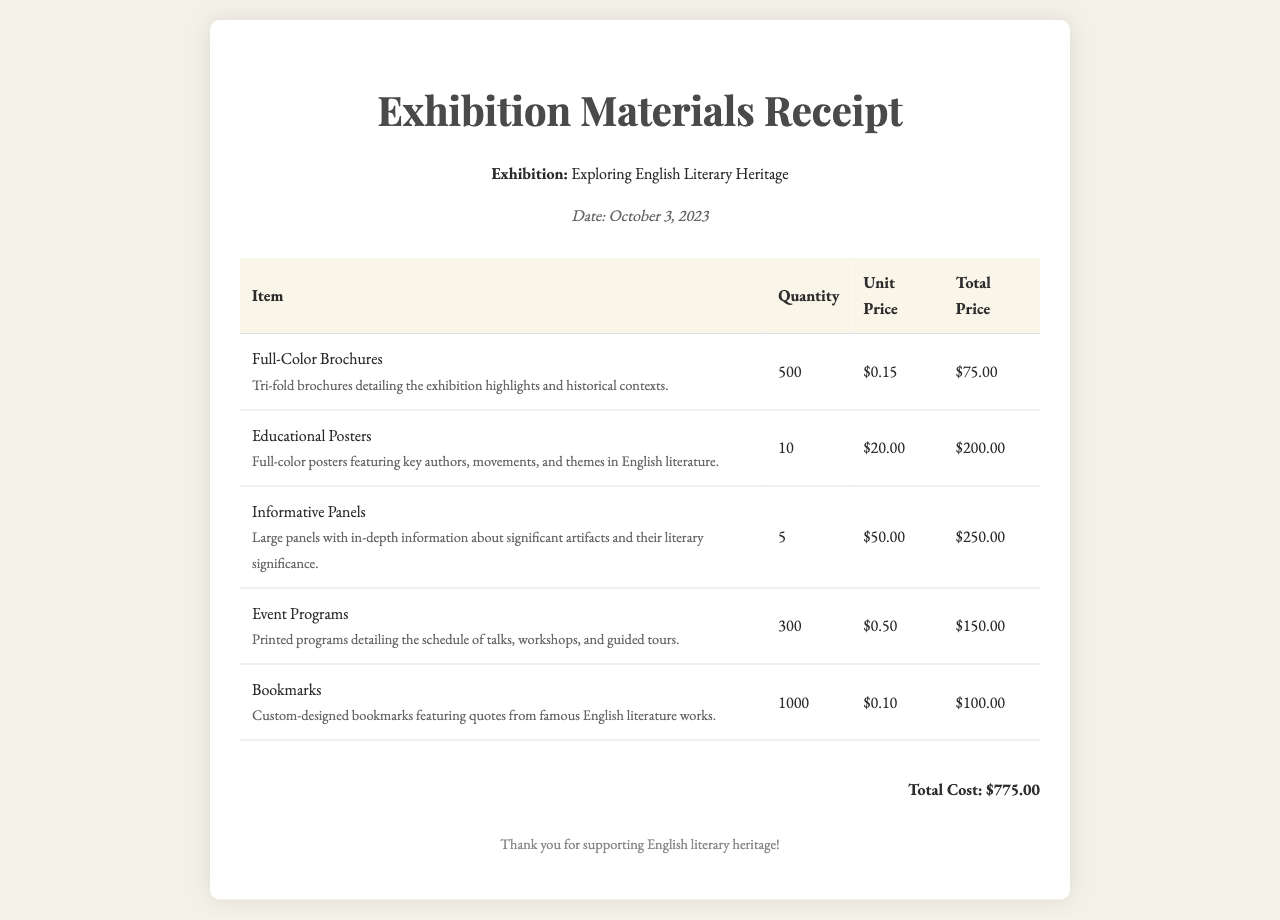What is the date of the receipt? The date is mentioned in the header of the document as October 3, 2023.
Answer: October 3, 2023 How many full-color brochures were printed? The quantity of full-color brochures is listed in the table under "Quantity" for that item, which states 500.
Answer: 500 What is the unit price of educational posters? The unit price for educational posters can be found in the table under "Unit Price," which shows $20.00.
Answer: $20.00 What is the total cost of all items? The total cost is stated at the end of the document, summing all individual item costs, totaling $775.00.
Answer: $775.00 What is the description of the informative panels? The description provided in the document details what informative panels represent, which is large panels with in-depth information about significant artifacts and their literary significance.
Answer: Large panels with in-depth information about significant artifacts and their literary significance How many bookmarks were ordered? The quantity of bookmarks is stated in the document as 1000 under the "Quantity" column.
Answer: 1000 What is the total price of event programs? The total price for event programs can be found in the table, which shows $150.00 in the "Total Price" column for that item.
Answer: $150.00 Which exhibition is mentioned in the receipt? The exhibition name is mentioned in the header of the receipt as “Exploring English Literary Heritage.”
Answer: Exploring English Literary Heritage 